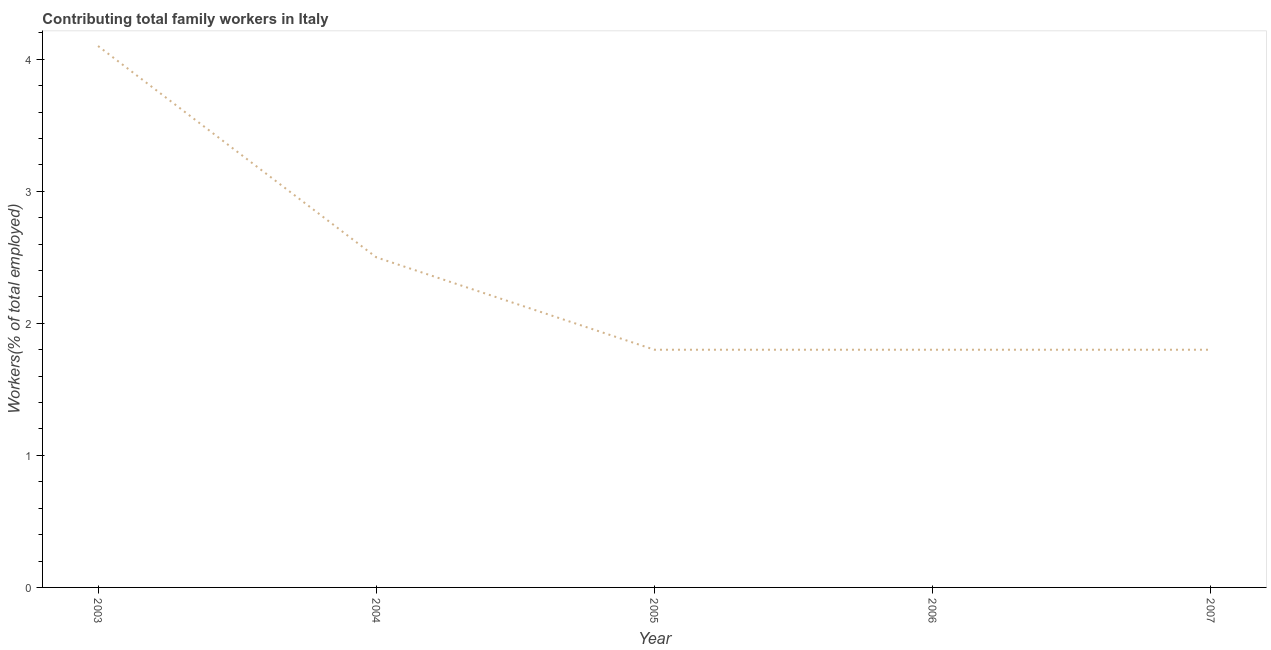What is the contributing family workers in 2006?
Give a very brief answer. 1.8. Across all years, what is the maximum contributing family workers?
Provide a short and direct response. 4.1. Across all years, what is the minimum contributing family workers?
Give a very brief answer. 1.8. In which year was the contributing family workers maximum?
Give a very brief answer. 2003. In which year was the contributing family workers minimum?
Provide a short and direct response. 2005. What is the sum of the contributing family workers?
Offer a very short reply. 12. What is the average contributing family workers per year?
Your response must be concise. 2.4. What is the median contributing family workers?
Make the answer very short. 1.8. What is the ratio of the contributing family workers in 2006 to that in 2007?
Provide a succinct answer. 1. Is the contributing family workers in 2004 less than that in 2006?
Your answer should be compact. No. What is the difference between the highest and the second highest contributing family workers?
Keep it short and to the point. 1.6. What is the difference between the highest and the lowest contributing family workers?
Your answer should be compact. 2.3. Does the graph contain any zero values?
Give a very brief answer. No. What is the title of the graph?
Offer a very short reply. Contributing total family workers in Italy. What is the label or title of the X-axis?
Your answer should be very brief. Year. What is the label or title of the Y-axis?
Provide a succinct answer. Workers(% of total employed). What is the Workers(% of total employed) of 2003?
Provide a succinct answer. 4.1. What is the Workers(% of total employed) of 2005?
Your response must be concise. 1.8. What is the Workers(% of total employed) in 2006?
Give a very brief answer. 1.8. What is the Workers(% of total employed) in 2007?
Give a very brief answer. 1.8. What is the difference between the Workers(% of total employed) in 2003 and 2004?
Your answer should be compact. 1.6. What is the difference between the Workers(% of total employed) in 2003 and 2005?
Offer a very short reply. 2.3. What is the difference between the Workers(% of total employed) in 2003 and 2006?
Offer a very short reply. 2.3. What is the difference between the Workers(% of total employed) in 2003 and 2007?
Offer a terse response. 2.3. What is the difference between the Workers(% of total employed) in 2004 and 2005?
Provide a short and direct response. 0.7. What is the difference between the Workers(% of total employed) in 2004 and 2006?
Ensure brevity in your answer.  0.7. What is the difference between the Workers(% of total employed) in 2005 and 2006?
Make the answer very short. 0. What is the difference between the Workers(% of total employed) in 2005 and 2007?
Your answer should be compact. 0. What is the ratio of the Workers(% of total employed) in 2003 to that in 2004?
Provide a succinct answer. 1.64. What is the ratio of the Workers(% of total employed) in 2003 to that in 2005?
Offer a very short reply. 2.28. What is the ratio of the Workers(% of total employed) in 2003 to that in 2006?
Your answer should be very brief. 2.28. What is the ratio of the Workers(% of total employed) in 2003 to that in 2007?
Offer a very short reply. 2.28. What is the ratio of the Workers(% of total employed) in 2004 to that in 2005?
Make the answer very short. 1.39. What is the ratio of the Workers(% of total employed) in 2004 to that in 2006?
Your answer should be compact. 1.39. What is the ratio of the Workers(% of total employed) in 2004 to that in 2007?
Your response must be concise. 1.39. What is the ratio of the Workers(% of total employed) in 2005 to that in 2007?
Your answer should be compact. 1. What is the ratio of the Workers(% of total employed) in 2006 to that in 2007?
Make the answer very short. 1. 